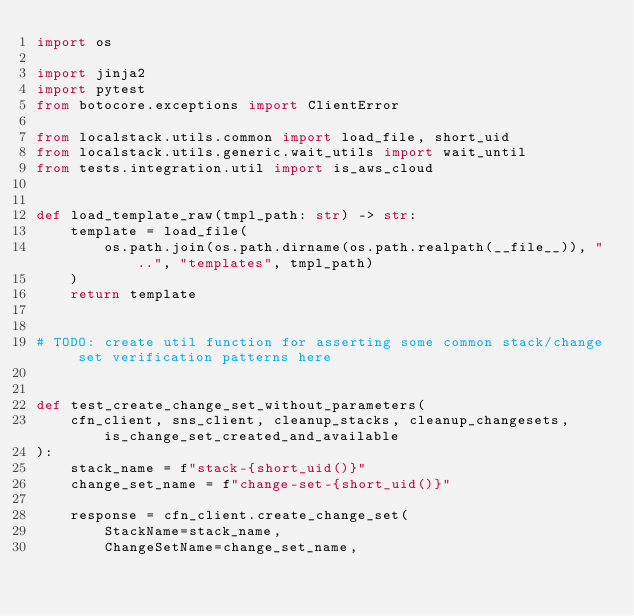<code> <loc_0><loc_0><loc_500><loc_500><_Python_>import os

import jinja2
import pytest
from botocore.exceptions import ClientError

from localstack.utils.common import load_file, short_uid
from localstack.utils.generic.wait_utils import wait_until
from tests.integration.util import is_aws_cloud


def load_template_raw(tmpl_path: str) -> str:
    template = load_file(
        os.path.join(os.path.dirname(os.path.realpath(__file__)), "..", "templates", tmpl_path)
    )
    return template


# TODO: create util function for asserting some common stack/change set verification patterns here


def test_create_change_set_without_parameters(
    cfn_client, sns_client, cleanup_stacks, cleanup_changesets, is_change_set_created_and_available
):
    stack_name = f"stack-{short_uid()}"
    change_set_name = f"change-set-{short_uid()}"

    response = cfn_client.create_change_set(
        StackName=stack_name,
        ChangeSetName=change_set_name,</code> 